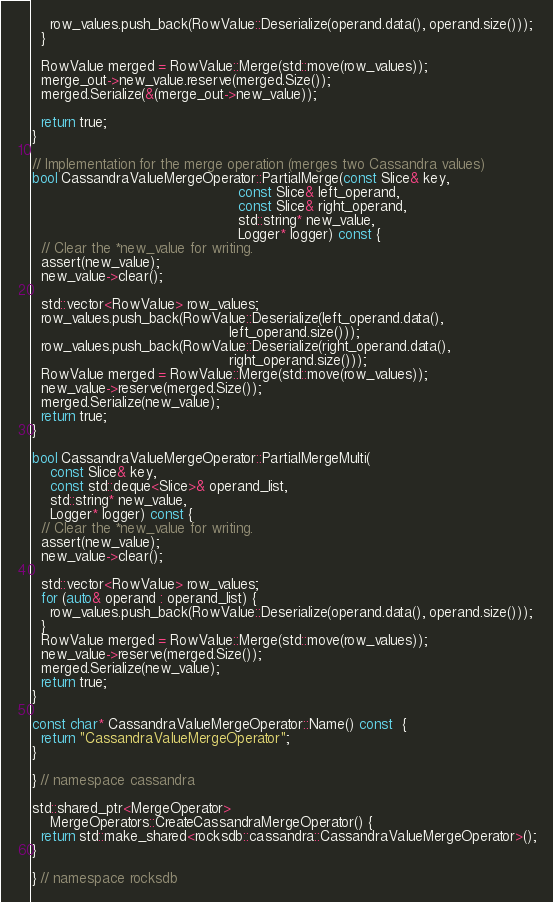<code> <loc_0><loc_0><loc_500><loc_500><_C++_>    row_values.push_back(RowValue::Deserialize(operand.data(), operand.size()));
  }

  RowValue merged = RowValue::Merge(std::move(row_values));
  merge_out->new_value.reserve(merged.Size());
  merged.Serialize(&(merge_out->new_value));

  return true;
}

// Implementation for the merge operation (merges two Cassandra values)
bool CassandraValueMergeOperator::PartialMerge(const Slice& key,
                                               const Slice& left_operand,
                                               const Slice& right_operand,
                                               std::string* new_value,
                                               Logger* logger) const {
  // Clear the *new_value for writing.
  assert(new_value);
  new_value->clear();

  std::vector<RowValue> row_values;
  row_values.push_back(RowValue::Deserialize(left_operand.data(),
                                             left_operand.size()));
  row_values.push_back(RowValue::Deserialize(right_operand.data(),
                                             right_operand.size()));
  RowValue merged = RowValue::Merge(std::move(row_values));
  new_value->reserve(merged.Size());
  merged.Serialize(new_value);
  return true;
}

bool CassandraValueMergeOperator::PartialMergeMulti(
    const Slice& key,
    const std::deque<Slice>& operand_list,
    std::string* new_value,
    Logger* logger) const {
  // Clear the *new_value for writing.
  assert(new_value);
  new_value->clear();

  std::vector<RowValue> row_values;
  for (auto& operand : operand_list) {
    row_values.push_back(RowValue::Deserialize(operand.data(), operand.size()));
  }
  RowValue merged = RowValue::Merge(std::move(row_values));
  new_value->reserve(merged.Size());
  merged.Serialize(new_value);
  return true;
}

const char* CassandraValueMergeOperator::Name() const  {
  return "CassandraValueMergeOperator";
}

} // namespace cassandra

std::shared_ptr<MergeOperator>
    MergeOperators::CreateCassandraMergeOperator() {
  return std::make_shared<rocksdb::cassandra::CassandraValueMergeOperator>();
}

} // namespace rocksdb
</code> 